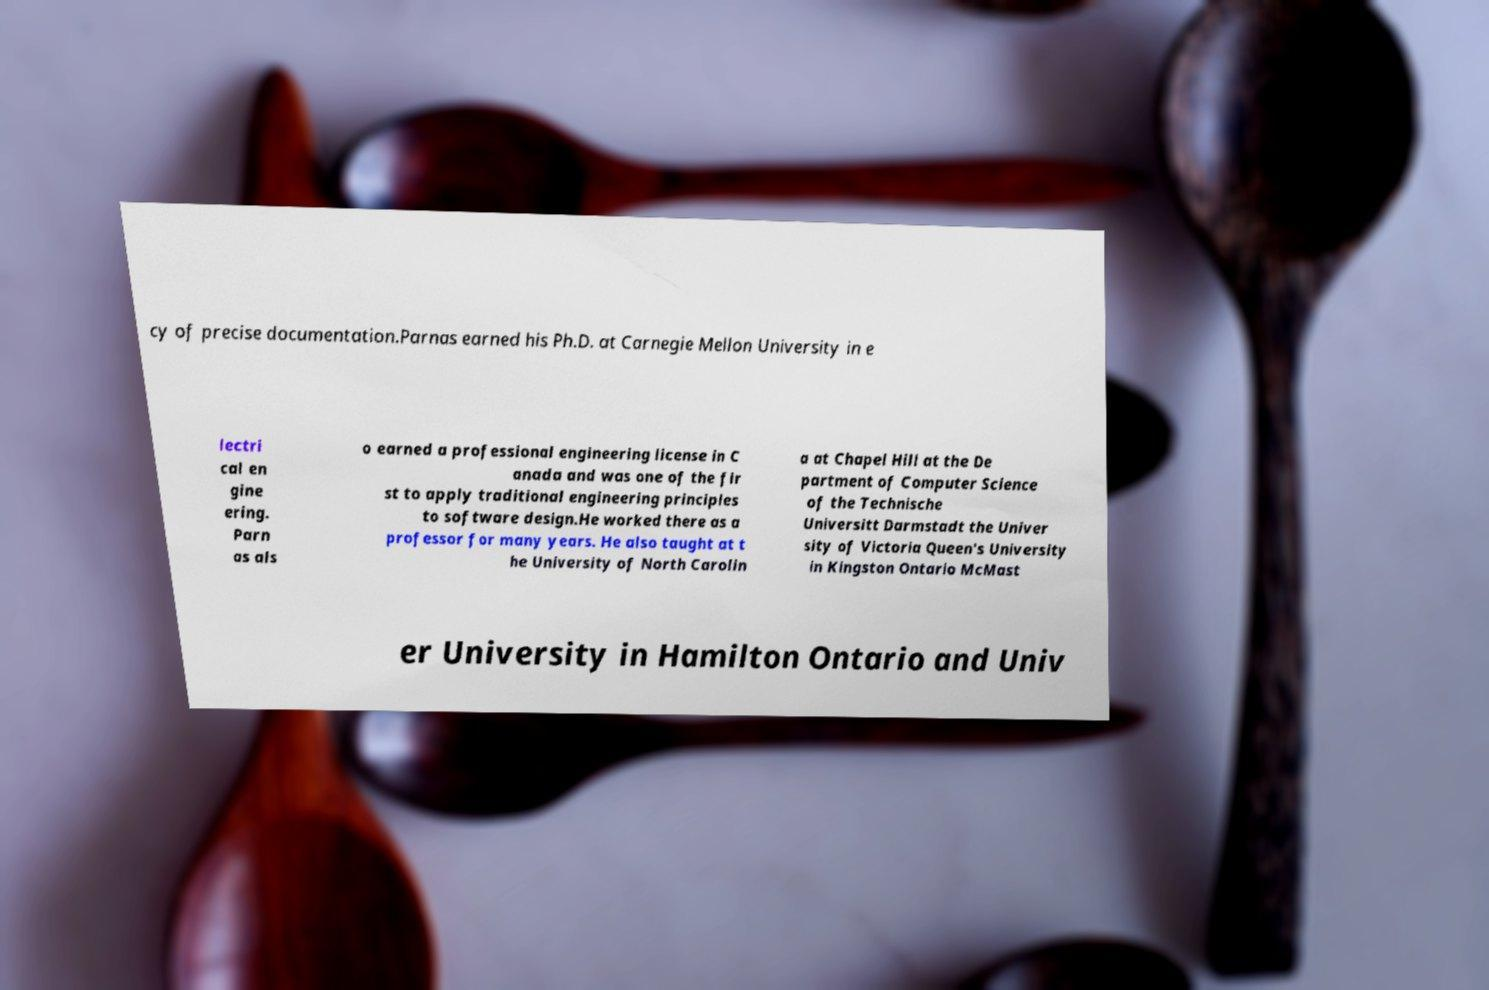What messages or text are displayed in this image? I need them in a readable, typed format. cy of precise documentation.Parnas earned his Ph.D. at Carnegie Mellon University in e lectri cal en gine ering. Parn as als o earned a professional engineering license in C anada and was one of the fir st to apply traditional engineering principles to software design.He worked there as a professor for many years. He also taught at t he University of North Carolin a at Chapel Hill at the De partment of Computer Science of the Technische Universitt Darmstadt the Univer sity of Victoria Queen's University in Kingston Ontario McMast er University in Hamilton Ontario and Univ 